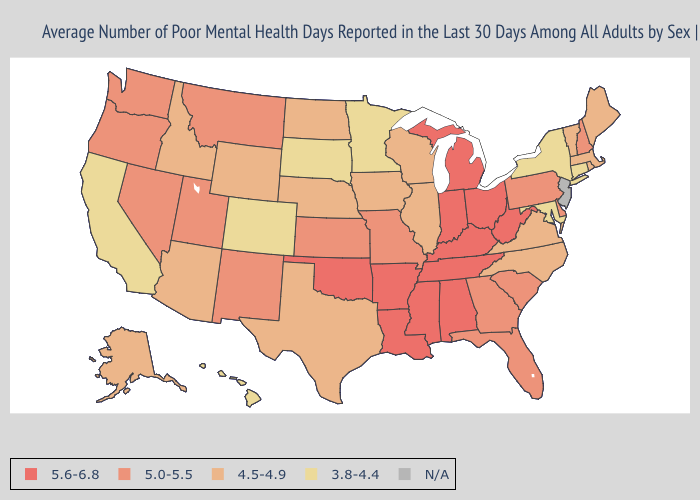Does Missouri have the highest value in the USA?
Give a very brief answer. No. What is the lowest value in the Northeast?
Write a very short answer. 3.8-4.4. Among the states that border Maryland , does West Virginia have the highest value?
Concise answer only. Yes. What is the value of Oklahoma?
Concise answer only. 5.6-6.8. Does the map have missing data?
Quick response, please. Yes. What is the value of Arkansas?
Write a very short answer. 5.6-6.8. Among the states that border New Hampshire , which have the highest value?
Keep it brief. Maine, Massachusetts, Vermont. Does the first symbol in the legend represent the smallest category?
Write a very short answer. No. What is the highest value in the South ?
Write a very short answer. 5.6-6.8. What is the value of Idaho?
Short answer required. 4.5-4.9. Among the states that border Kentucky , does Indiana have the highest value?
Quick response, please. Yes. What is the value of Wyoming?
Write a very short answer. 4.5-4.9. Name the states that have a value in the range 3.8-4.4?
Concise answer only. California, Colorado, Connecticut, Hawaii, Maryland, Minnesota, New York, South Dakota. Among the states that border Vermont , does Massachusetts have the highest value?
Quick response, please. No. 